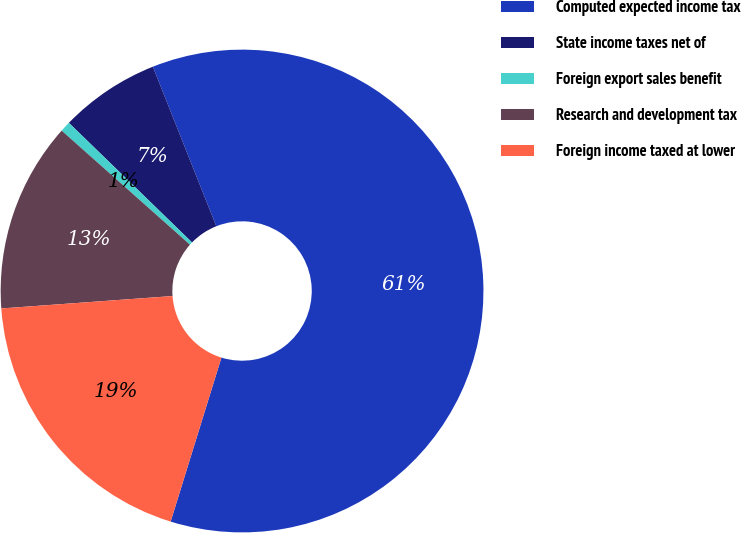<chart> <loc_0><loc_0><loc_500><loc_500><pie_chart><fcel>Computed expected income tax<fcel>State income taxes net of<fcel>Foreign export sales benefit<fcel>Research and development tax<fcel>Foreign income taxed at lower<nl><fcel>60.81%<fcel>6.71%<fcel>0.7%<fcel>12.72%<fcel>19.07%<nl></chart> 